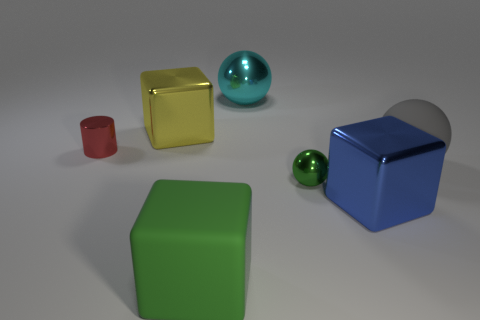Is there a sense of harmony or balance in how the objects are arranged? Yes, the arrangement of objects of varying sizes, colors, and finishes seems to suggest a deliberate attempt at visual balance, creating an aesthetically pleasing composition. 